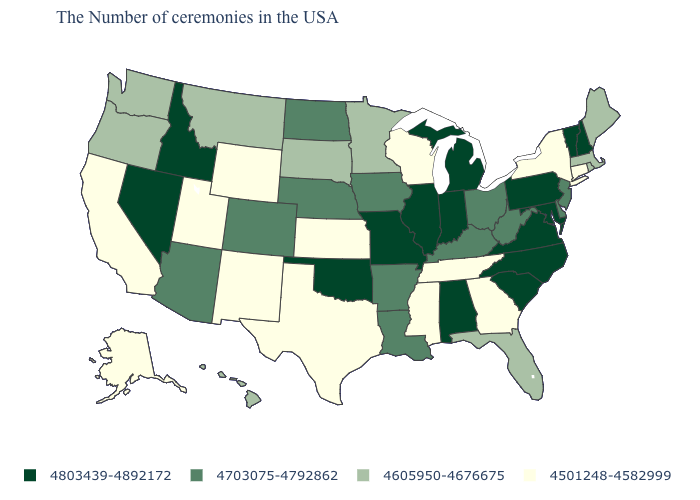What is the lowest value in the USA?
Write a very short answer. 4501248-4582999. Does the first symbol in the legend represent the smallest category?
Keep it brief. No. What is the value of Connecticut?
Give a very brief answer. 4501248-4582999. What is the value of Arizona?
Quick response, please. 4703075-4792862. Name the states that have a value in the range 4605950-4676675?
Answer briefly. Maine, Massachusetts, Rhode Island, Florida, Minnesota, South Dakota, Montana, Washington, Oregon, Hawaii. What is the value of Colorado?
Keep it brief. 4703075-4792862. What is the highest value in the USA?
Be succinct. 4803439-4892172. Name the states that have a value in the range 4501248-4582999?
Write a very short answer. Connecticut, New York, Georgia, Tennessee, Wisconsin, Mississippi, Kansas, Texas, Wyoming, New Mexico, Utah, California, Alaska. What is the lowest value in states that border Oklahoma?
Write a very short answer. 4501248-4582999. Name the states that have a value in the range 4501248-4582999?
Be succinct. Connecticut, New York, Georgia, Tennessee, Wisconsin, Mississippi, Kansas, Texas, Wyoming, New Mexico, Utah, California, Alaska. What is the highest value in the USA?
Quick response, please. 4803439-4892172. Does Georgia have a higher value than Texas?
Short answer required. No. How many symbols are there in the legend?
Write a very short answer. 4. Which states hav the highest value in the Northeast?
Concise answer only. New Hampshire, Vermont, Pennsylvania. Does California have the lowest value in the USA?
Short answer required. Yes. 